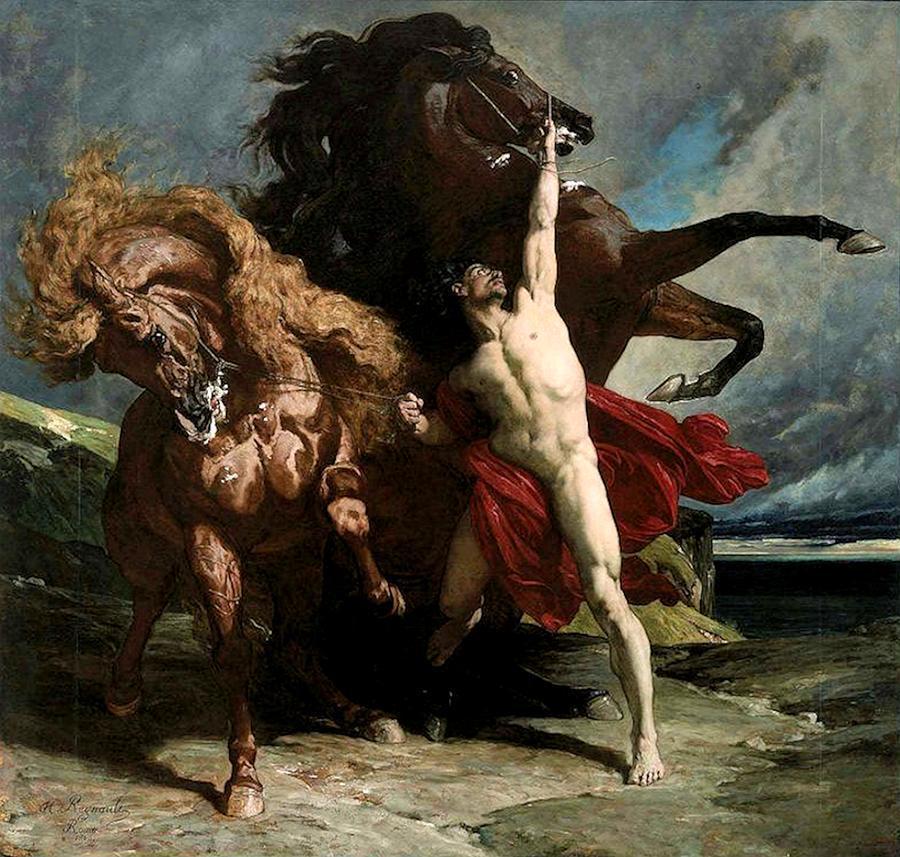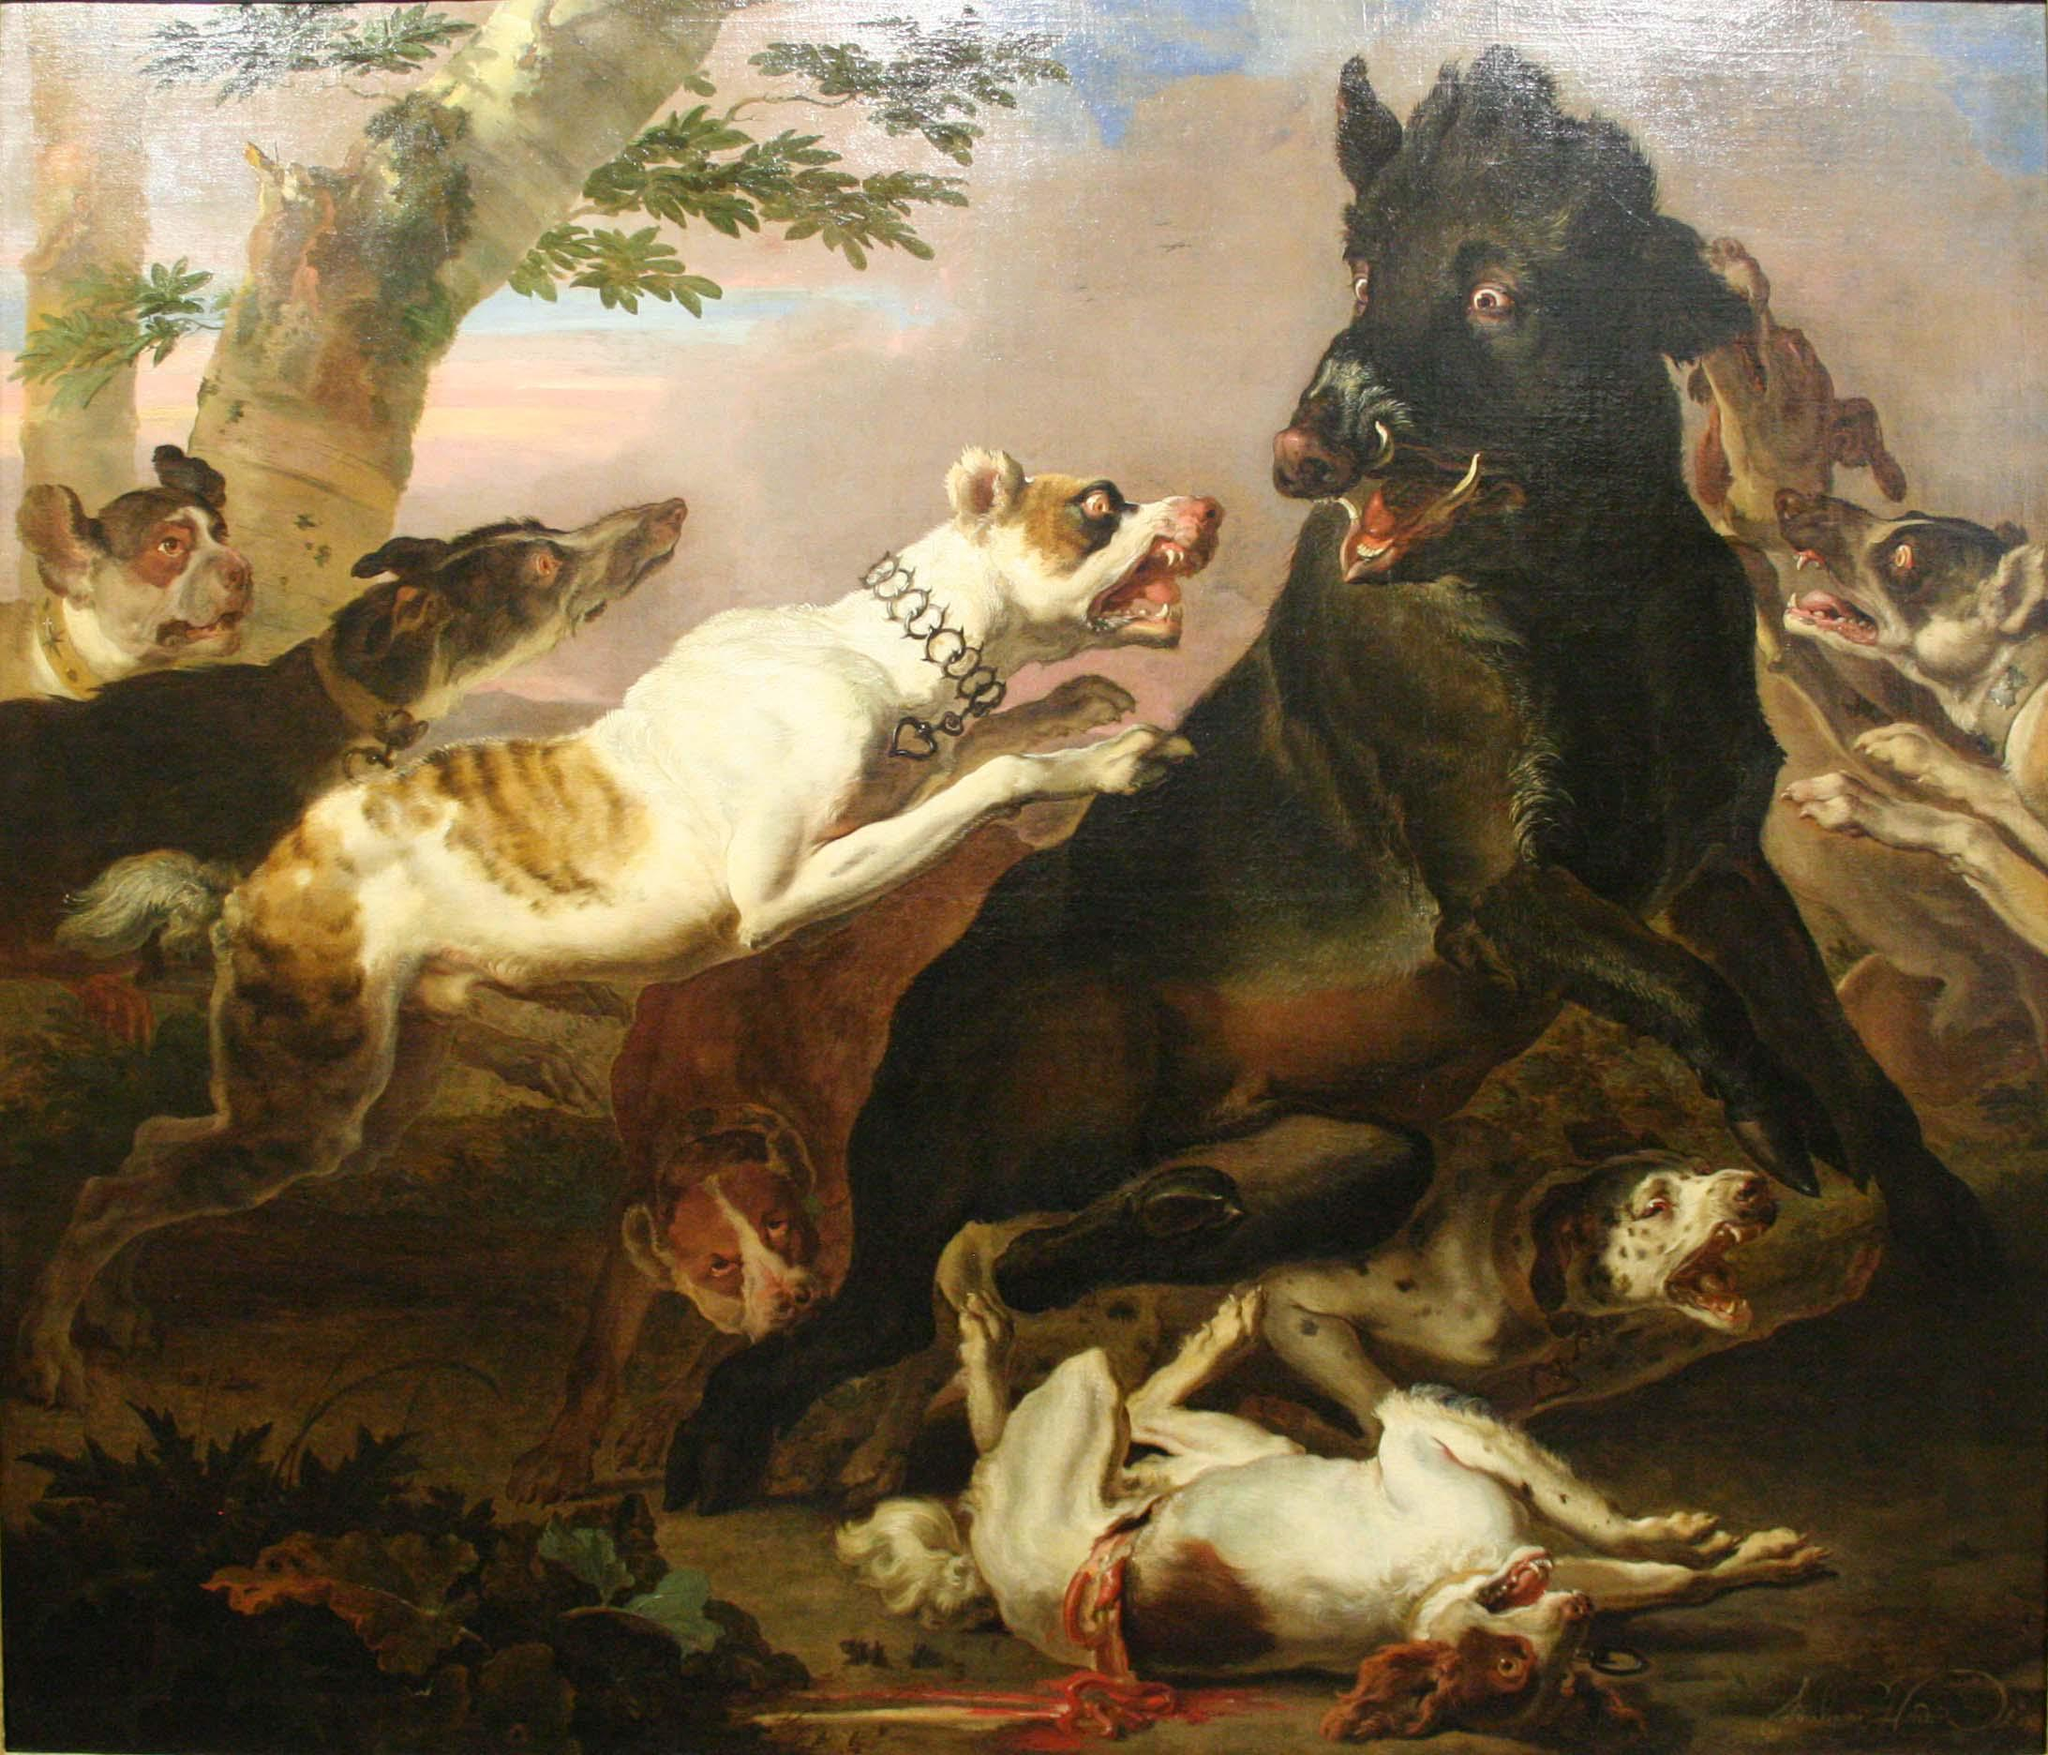The first image is the image on the left, the second image is the image on the right. Given the left and right images, does the statement "There is at least one horse in the same image as a man." hold true? Answer yes or no. Yes. 